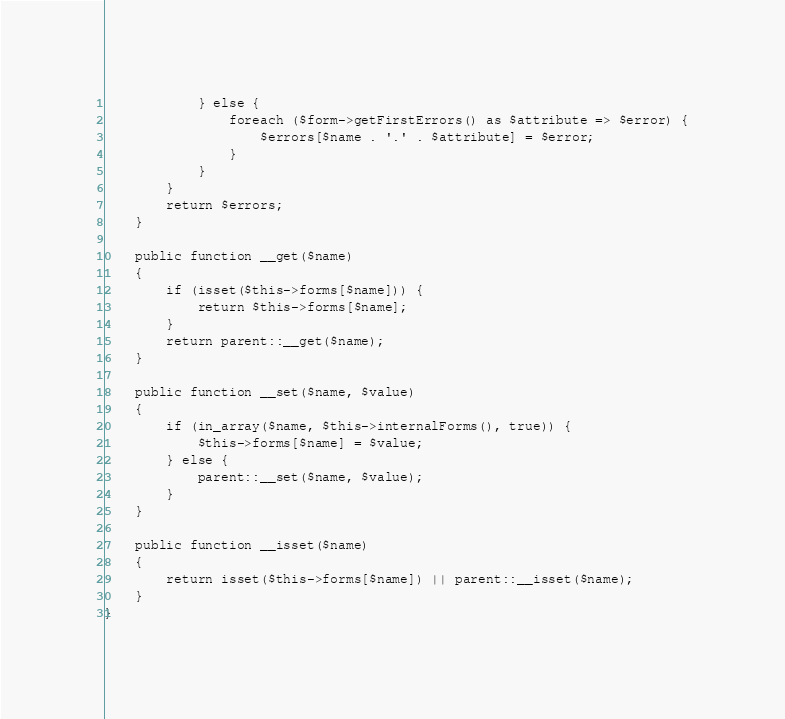<code> <loc_0><loc_0><loc_500><loc_500><_PHP_>            } else {
                foreach ($form->getFirstErrors() as $attribute => $error) {
                    $errors[$name . '.' . $attribute] = $error;
                }
            }
        }
        return $errors;
    }

    public function __get($name)
    {
        if (isset($this->forms[$name])) {
            return $this->forms[$name];
        }
        return parent::__get($name);
    }

    public function __set($name, $value)
    {
        if (in_array($name, $this->internalForms(), true)) {
            $this->forms[$name] = $value;
        } else {
            parent::__set($name, $value);
        }
    }

    public function __isset($name)
    {
        return isset($this->forms[$name]) || parent::__isset($name);
    }
}
</code> 